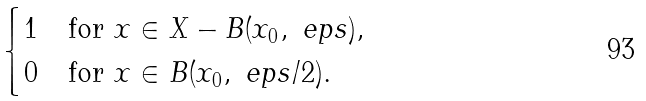Convert formula to latex. <formula><loc_0><loc_0><loc_500><loc_500>\begin{cases} 1 & \text {for } x \in X - B ( x _ { 0 } , \ e p s ) , \\ 0 & \text {for } x \in B ( x _ { 0 } , \ e p s / 2 ) . \end{cases}</formula> 